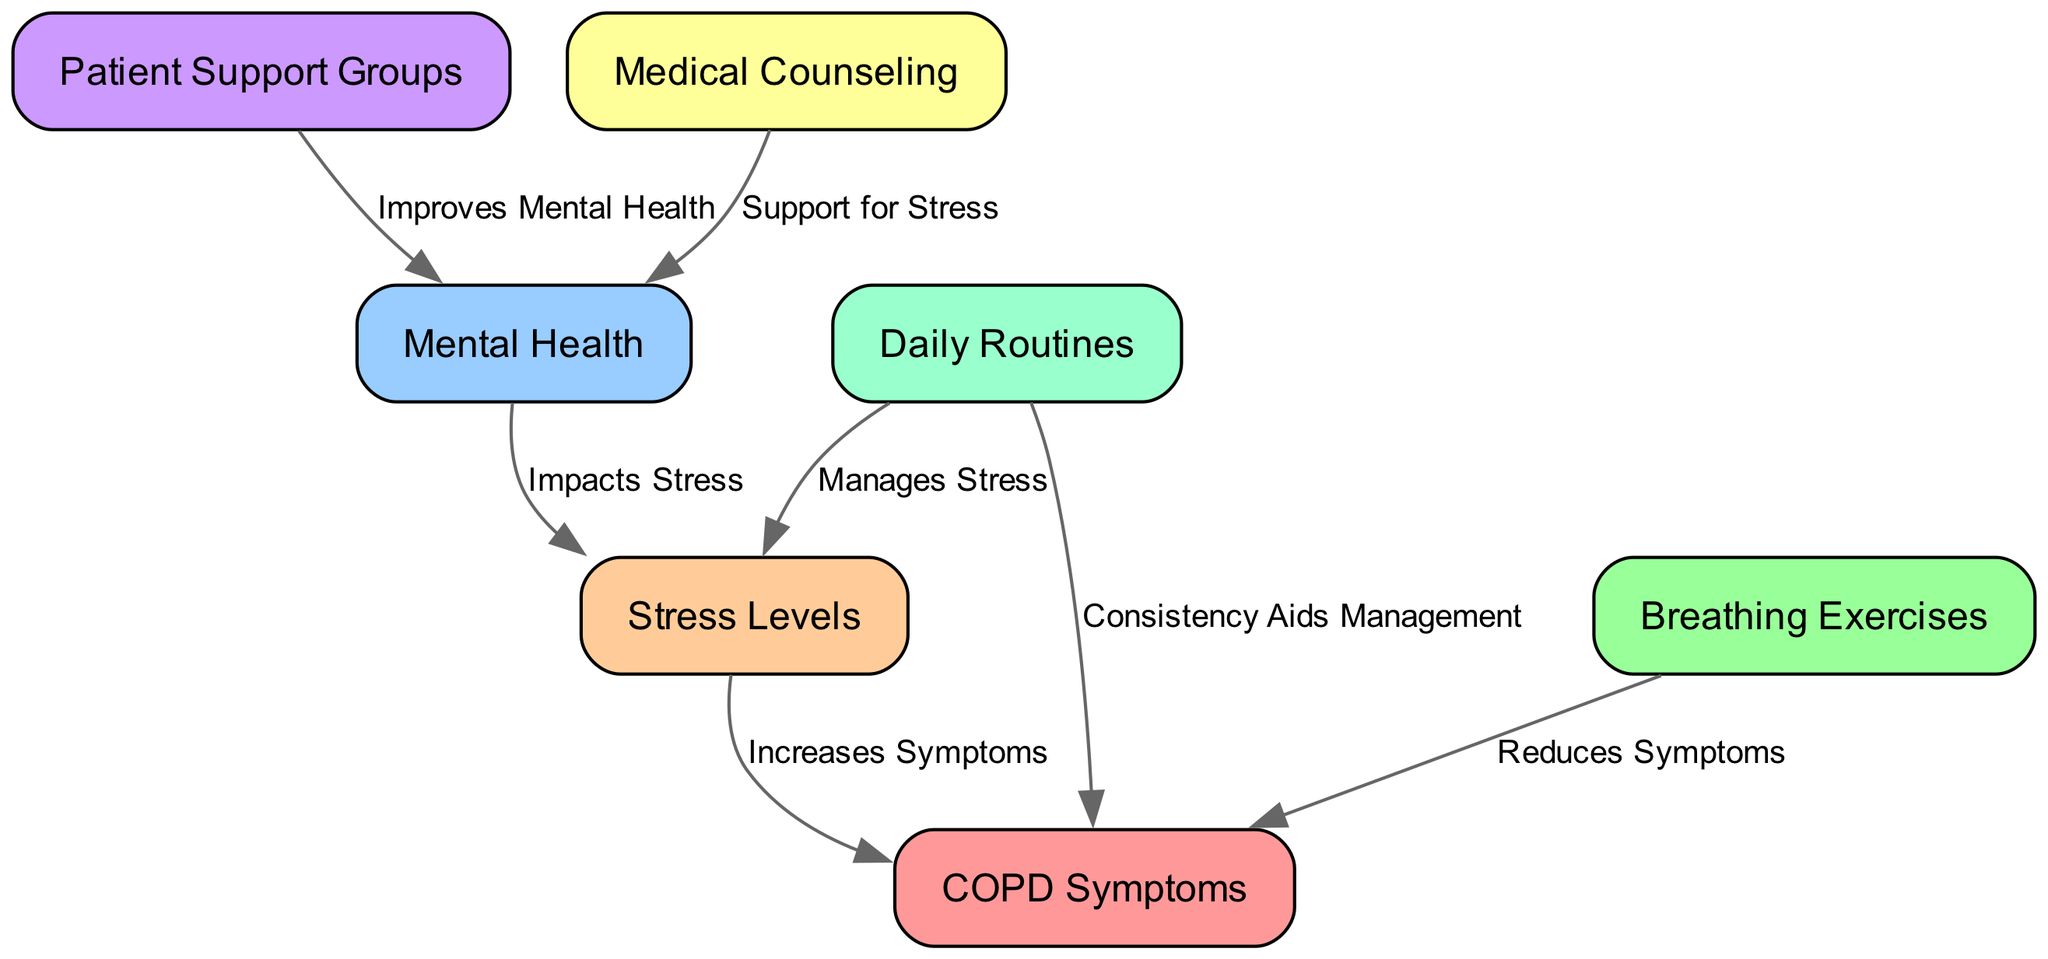What are the total number of nodes in the diagram? The diagram contains seven distinct nodes: COPD Symptoms, Stress Levels, Mental Health, Breathing Exercises, Patient Support Groups, Medical Counseling, and Daily Routines. Therefore, counting these reveals that there are a total of seven nodes in the diagram.
Answer: 7 Which node is connected to 'Stress Levels' that lists an effect? The edge from 'Mental Health' to 'Stress Levels' indicates that Mental Health impacts Stress, showcasing a direct influence between the two nodes. Thus, 'Mental Health' is the node that connects to 'Stress Levels' with an effect.
Answer: Mental Health What effect does 'Breathing Exercises' have on 'COPD Symptoms'? The edge from 'Breathing Exercises' to 'COPD Symptoms' signifies that Breathing Exercises reduces Symptoms, showing a beneficial effect on the symptoms experienced by COPD patients.
Answer: Reduces Symptoms How many edges originate from 'Daily Routines'? Analyzing the diagram reveals that there are two edges originating from 'Daily Routines': one directed towards 'Stress Levels' and another directed towards 'COPD Symptoms'. This indicates that 'Daily Routines' influences both stress levels and the management of symptoms.
Answer: 2 Which node has no incoming edges? Upon close examination of the nodes, 'Breathing Exercises' is found to have no edges directed towards it, meaning that it does not receive influence from any other nodes in the diagram. Thus, it stands alone without incoming connections.
Answer: Breathing Exercises What is the relationship between 'Patient Support Groups' and 'Mental Health'? The edge from 'Patient Support Groups' to 'Mental Health' indicates that Patient Support Groups improve Mental Health, establishing a clear positive relationship between these two factors in the context of COPD management.
Answer: Improves Mental Health What role do 'Daily Routines' play in stress management? There are two edges from 'Daily Routines': one to 'Stress Levels' that manages stress directly and another that indicates consistency aids management of COPD symptoms, illustrating that daily routines have a supportive role in stress management.
Answer: Manages Stress What node increases 'COPD Symptoms'? The edge connecting 'Stress Levels' to 'COPD Symptoms' demonstrates that increasing stress levels directly contributes to the exacerbation of COPD symptoms. Therefore, 'Stress Levels' is the node that increases COPD Symptoms.
Answer: Increases Symptoms 